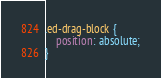<code> <loc_0><loc_0><loc_500><loc_500><_CSS_>.ed-drag-block {
    position: absolute;
}</code> 